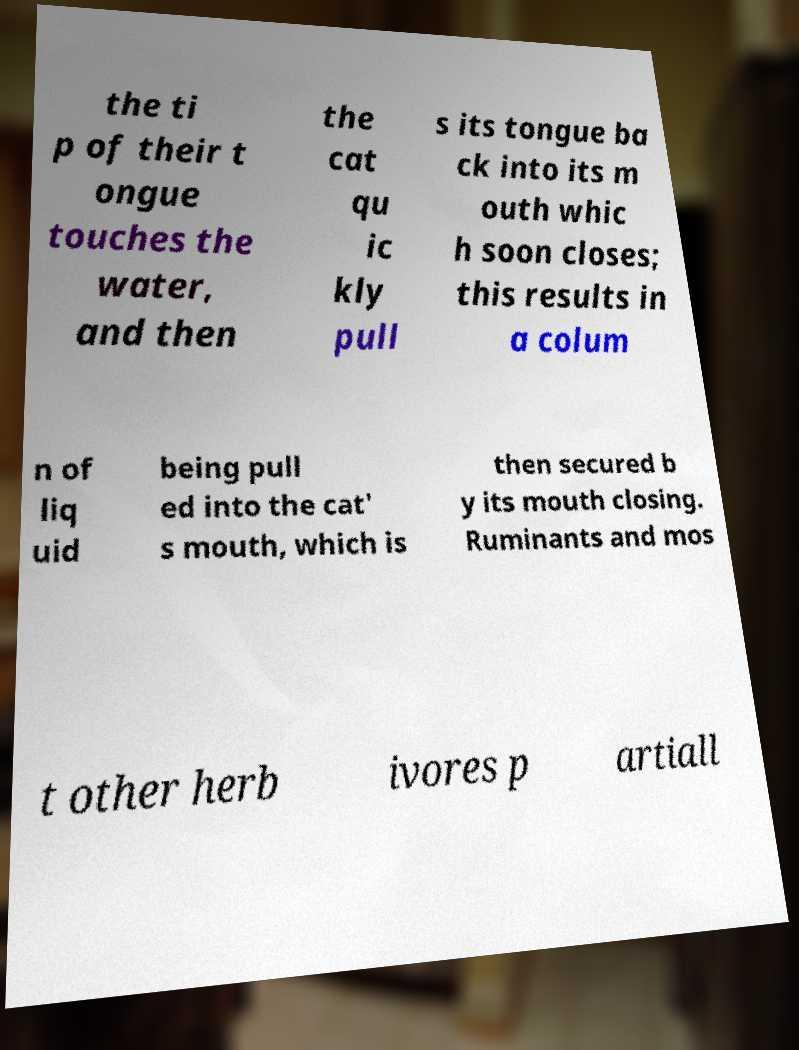Could you assist in decoding the text presented in this image and type it out clearly? the ti p of their t ongue touches the water, and then the cat qu ic kly pull s its tongue ba ck into its m outh whic h soon closes; this results in a colum n of liq uid being pull ed into the cat' s mouth, which is then secured b y its mouth closing. Ruminants and mos t other herb ivores p artiall 